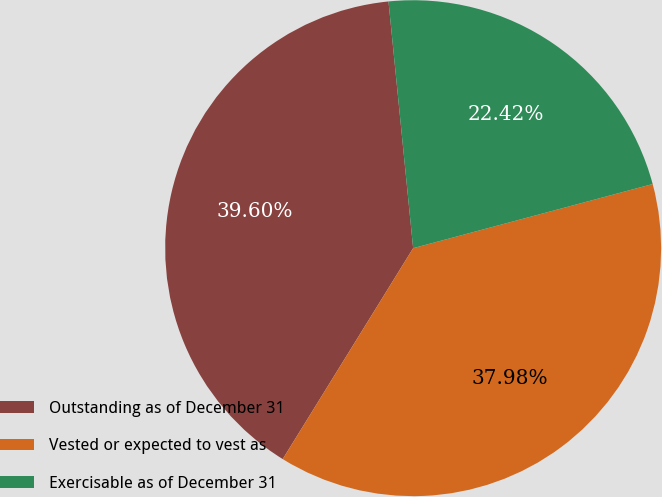Convert chart to OTSL. <chart><loc_0><loc_0><loc_500><loc_500><pie_chart><fcel>Outstanding as of December 31<fcel>Vested or expected to vest as<fcel>Exercisable as of December 31<nl><fcel>39.6%<fcel>37.98%<fcel>22.42%<nl></chart> 